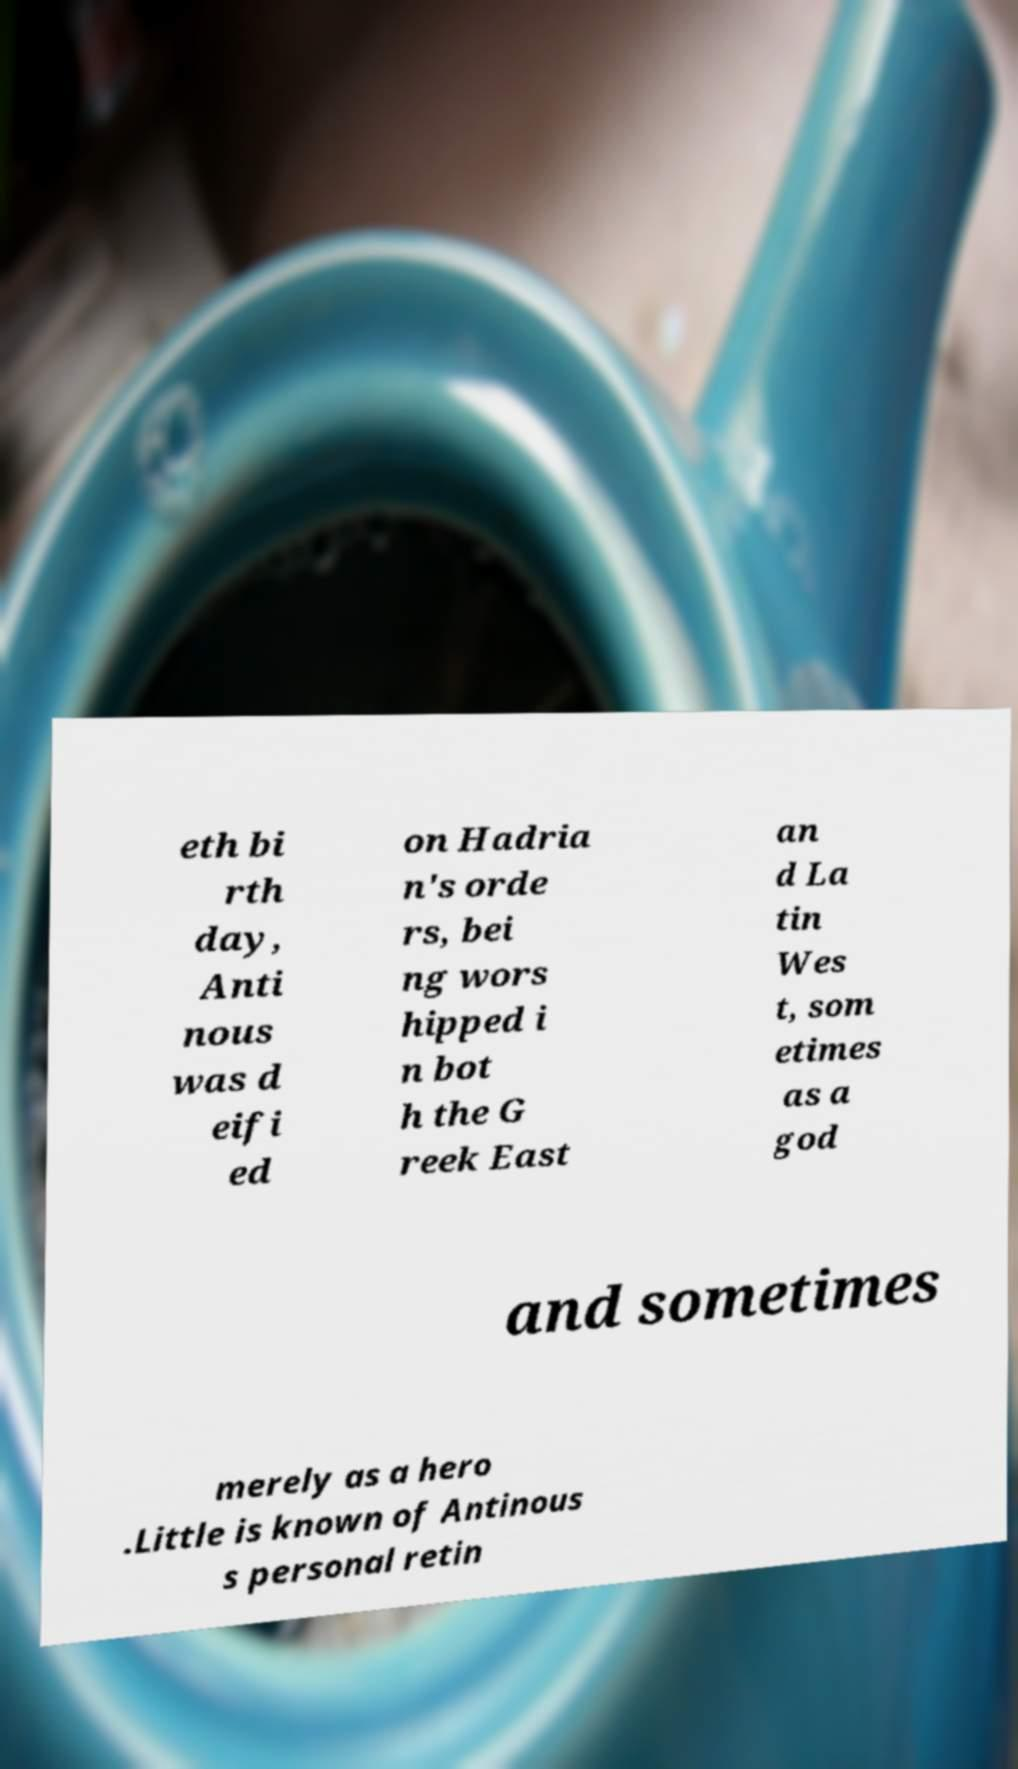Can you accurately transcribe the text from the provided image for me? eth bi rth day, Anti nous was d eifi ed on Hadria n's orde rs, bei ng wors hipped i n bot h the G reek East an d La tin Wes t, som etimes as a god and sometimes merely as a hero .Little is known of Antinous s personal retin 